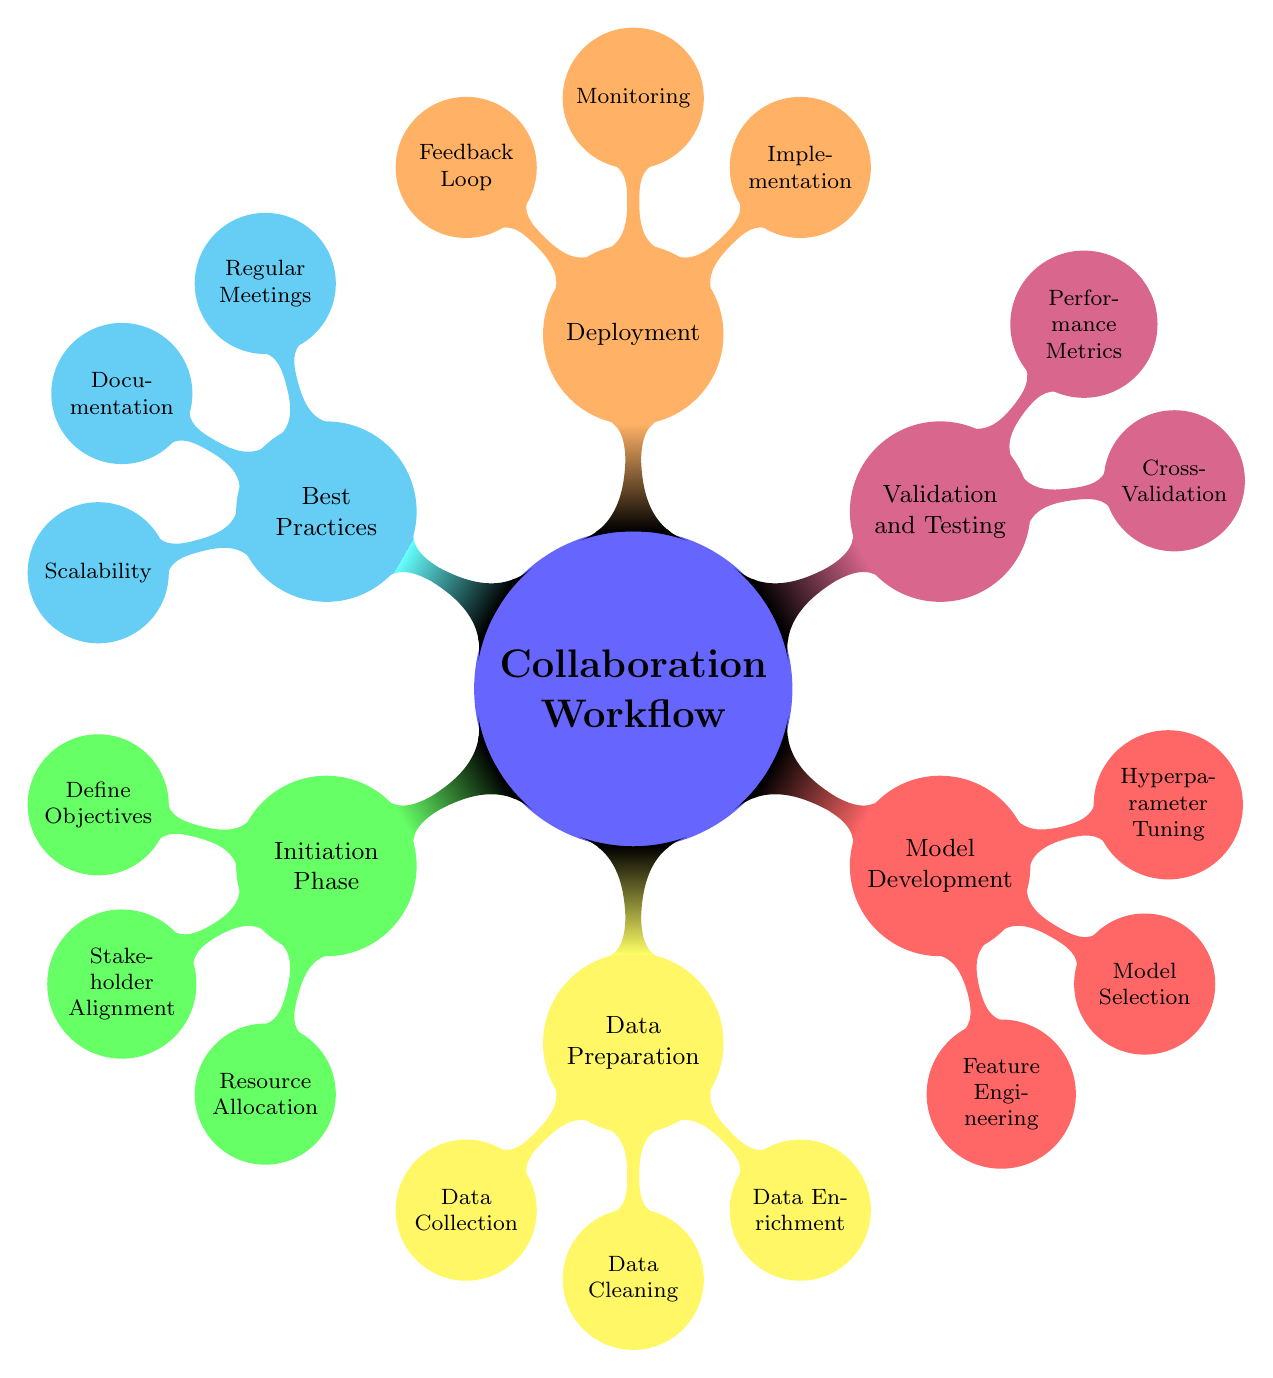What are the three nodes in the Initialization Phase? The Initialization Phase contains three nodes: Define Objectives, Stakeholder Alignment, and Resource Allocation. These nodes represent key activities in the initiation of the collaboration workflow.
Answer: Define Objectives, Stakeholder Alignment, Resource Allocation How many nodes are in the Data Preparation section? The Data Preparation section consists of three nodes: Data Collection, Data Cleaning, and Data Enrichment. Counting these nodes gives the total number.
Answer: 3 Which phase involves Hyperparameter Tuning? Hyperparameter Tuning is part of the Model Development phase, where predictive model performance is optimized through fine-tuning model parameters.
Answer: Model Development What is the main focus of the Deployment phase? The main focus of the Deployment phase includes the Implementation of the model, which integrates it into existing systems, alongside Monitoring and Feedback Loop processes.
Answer: Implementation, Monitoring, Feedback Loop How many Performance Metrics are listed under Validation and Testing? There are three Performance Metrics listed under Validation and Testing: Accuracy, RMSE, and MAE.
Answer: 3 Which best practice emphasizes consistent communication? The best practice that emphasizes consistent communication is Regular Meetings, highlighting the importance of syncing up periodically with stakeholders.
Answer: Regular Meetings What action is associated with the Data Cleaning node? The action associated with the Data Cleaning node is to remove inconsistencies in the data, ensuring quality and reliability in subsequent analysis.
Answer: Remove inconsistencies What do you need to do first according to the workflow? According to the workflow, the first action is to Define Objectives, which sets the foundation for the project's goals and directions.
Answer: Define Objectives 